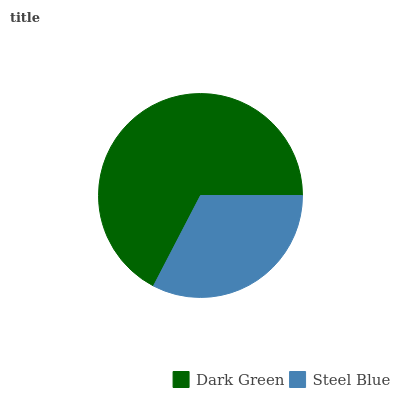Is Steel Blue the minimum?
Answer yes or no. Yes. Is Dark Green the maximum?
Answer yes or no. Yes. Is Steel Blue the maximum?
Answer yes or no. No. Is Dark Green greater than Steel Blue?
Answer yes or no. Yes. Is Steel Blue less than Dark Green?
Answer yes or no. Yes. Is Steel Blue greater than Dark Green?
Answer yes or no. No. Is Dark Green less than Steel Blue?
Answer yes or no. No. Is Dark Green the high median?
Answer yes or no. Yes. Is Steel Blue the low median?
Answer yes or no. Yes. Is Steel Blue the high median?
Answer yes or no. No. Is Dark Green the low median?
Answer yes or no. No. 